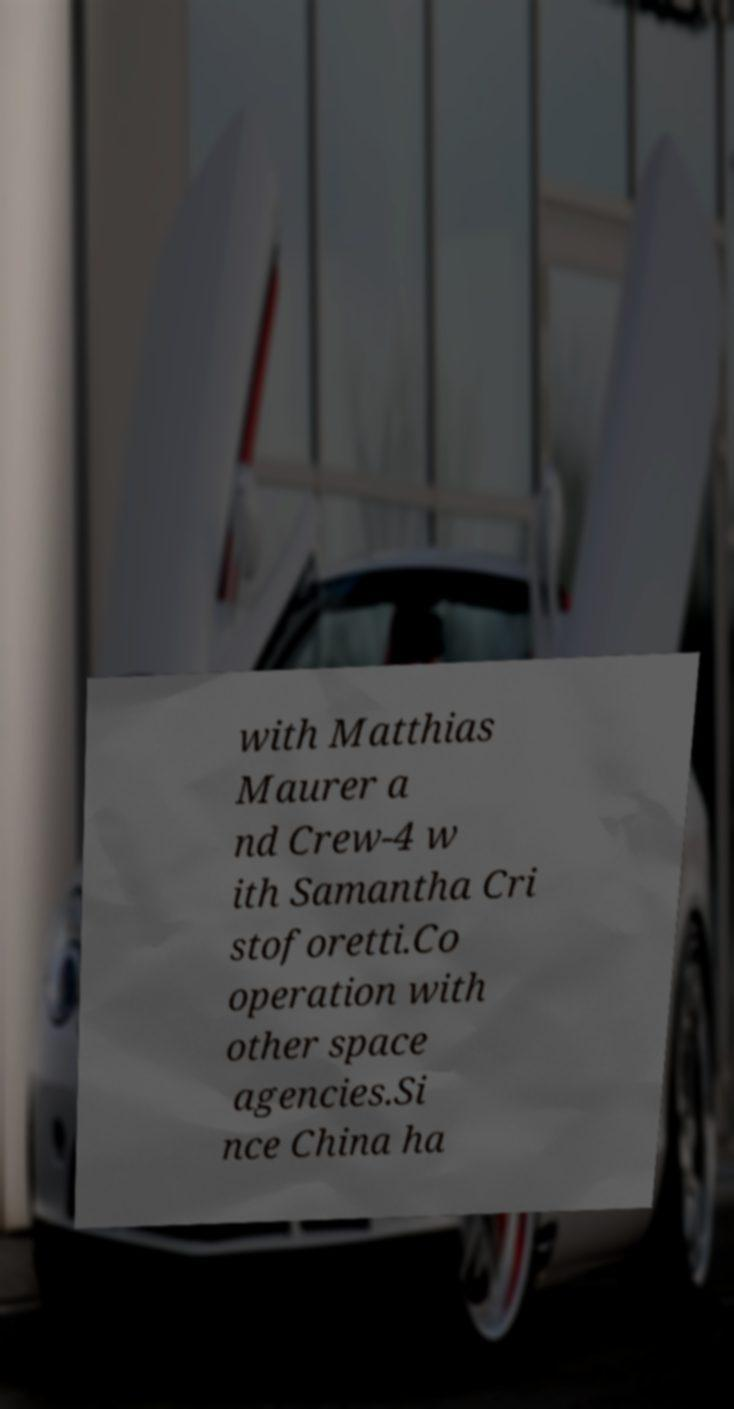Could you extract and type out the text from this image? with Matthias Maurer a nd Crew-4 w ith Samantha Cri stoforetti.Co operation with other space agencies.Si nce China ha 